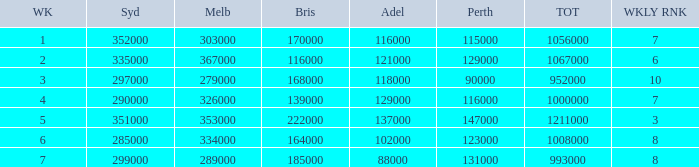How many viewers were there in Sydney for the episode when there were 334000 in Melbourne? 285000.0. 